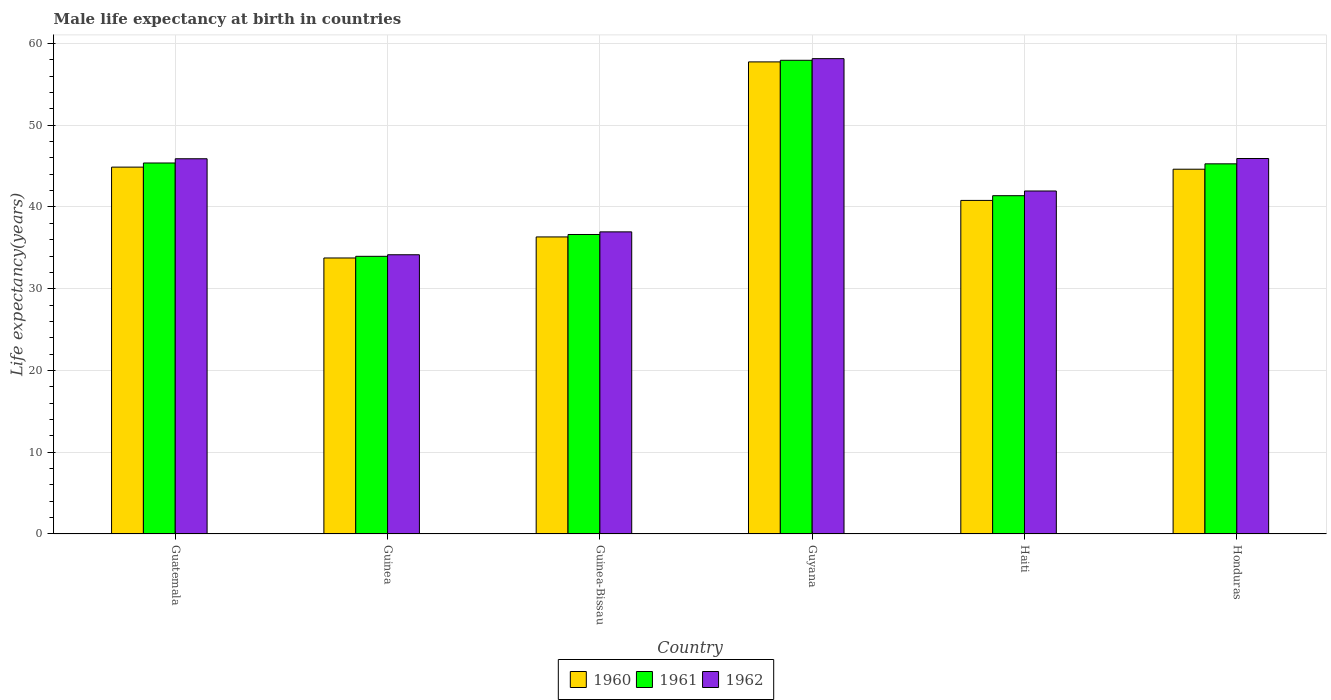How many groups of bars are there?
Your answer should be very brief. 6. Are the number of bars on each tick of the X-axis equal?
Offer a terse response. Yes. What is the label of the 6th group of bars from the left?
Provide a short and direct response. Honduras. What is the male life expectancy at birth in 1961 in Guyana?
Ensure brevity in your answer.  57.95. Across all countries, what is the maximum male life expectancy at birth in 1962?
Your answer should be compact. 58.15. Across all countries, what is the minimum male life expectancy at birth in 1961?
Provide a short and direct response. 33.97. In which country was the male life expectancy at birth in 1962 maximum?
Your answer should be compact. Guyana. In which country was the male life expectancy at birth in 1962 minimum?
Provide a succinct answer. Guinea. What is the total male life expectancy at birth in 1962 in the graph?
Your answer should be compact. 263.05. What is the difference between the male life expectancy at birth in 1962 in Guatemala and that in Guinea?
Offer a very short reply. 11.74. What is the difference between the male life expectancy at birth in 1960 in Guyana and the male life expectancy at birth in 1961 in Guinea-Bissau?
Ensure brevity in your answer.  21.11. What is the average male life expectancy at birth in 1960 per country?
Give a very brief answer. 43.03. What is the difference between the male life expectancy at birth of/in 1962 and male life expectancy at birth of/in 1960 in Guinea?
Give a very brief answer. 0.39. What is the ratio of the male life expectancy at birth in 1960 in Guyana to that in Honduras?
Make the answer very short. 1.29. Is the male life expectancy at birth in 1960 in Guatemala less than that in Honduras?
Your response must be concise. No. Is the difference between the male life expectancy at birth in 1962 in Guatemala and Guinea greater than the difference between the male life expectancy at birth in 1960 in Guatemala and Guinea?
Make the answer very short. Yes. What is the difference between the highest and the second highest male life expectancy at birth in 1961?
Provide a short and direct response. 12.67. What is the difference between the highest and the lowest male life expectancy at birth in 1961?
Provide a succinct answer. 23.98. In how many countries, is the male life expectancy at birth in 1961 greater than the average male life expectancy at birth in 1961 taken over all countries?
Keep it short and to the point. 3. Is the sum of the male life expectancy at birth in 1962 in Guinea and Honduras greater than the maximum male life expectancy at birth in 1961 across all countries?
Your answer should be compact. Yes. What does the 3rd bar from the right in Guyana represents?
Keep it short and to the point. 1960. Is it the case that in every country, the sum of the male life expectancy at birth in 1961 and male life expectancy at birth in 1960 is greater than the male life expectancy at birth in 1962?
Ensure brevity in your answer.  Yes. How many bars are there?
Offer a terse response. 18. Are all the bars in the graph horizontal?
Keep it short and to the point. No. How many countries are there in the graph?
Make the answer very short. 6. What is the difference between two consecutive major ticks on the Y-axis?
Offer a terse response. 10. Are the values on the major ticks of Y-axis written in scientific E-notation?
Make the answer very short. No. Does the graph contain grids?
Provide a short and direct response. Yes. Where does the legend appear in the graph?
Your answer should be very brief. Bottom center. How many legend labels are there?
Offer a very short reply. 3. How are the legend labels stacked?
Your answer should be compact. Horizontal. What is the title of the graph?
Provide a succinct answer. Male life expectancy at birth in countries. What is the label or title of the X-axis?
Give a very brief answer. Country. What is the label or title of the Y-axis?
Make the answer very short. Life expectancy(years). What is the Life expectancy(years) of 1960 in Guatemala?
Provide a succinct answer. 44.88. What is the Life expectancy(years) of 1961 in Guatemala?
Provide a short and direct response. 45.38. What is the Life expectancy(years) in 1962 in Guatemala?
Give a very brief answer. 45.9. What is the Life expectancy(years) in 1960 in Guinea?
Your response must be concise. 33.76. What is the Life expectancy(years) of 1961 in Guinea?
Your answer should be very brief. 33.97. What is the Life expectancy(years) in 1962 in Guinea?
Ensure brevity in your answer.  34.16. What is the Life expectancy(years) of 1960 in Guinea-Bissau?
Offer a very short reply. 36.34. What is the Life expectancy(years) of 1961 in Guinea-Bissau?
Your answer should be compact. 36.63. What is the Life expectancy(years) of 1962 in Guinea-Bissau?
Provide a succinct answer. 36.96. What is the Life expectancy(years) of 1960 in Guyana?
Provide a short and direct response. 57.75. What is the Life expectancy(years) in 1961 in Guyana?
Your response must be concise. 57.95. What is the Life expectancy(years) in 1962 in Guyana?
Ensure brevity in your answer.  58.15. What is the Life expectancy(years) of 1960 in Haiti?
Provide a short and direct response. 40.8. What is the Life expectancy(years) of 1961 in Haiti?
Keep it short and to the point. 41.38. What is the Life expectancy(years) in 1962 in Haiti?
Ensure brevity in your answer.  41.96. What is the Life expectancy(years) in 1960 in Honduras?
Ensure brevity in your answer.  44.62. What is the Life expectancy(years) in 1961 in Honduras?
Keep it short and to the point. 45.28. What is the Life expectancy(years) in 1962 in Honduras?
Make the answer very short. 45.93. Across all countries, what is the maximum Life expectancy(years) of 1960?
Offer a terse response. 57.75. Across all countries, what is the maximum Life expectancy(years) of 1961?
Your answer should be very brief. 57.95. Across all countries, what is the maximum Life expectancy(years) of 1962?
Make the answer very short. 58.15. Across all countries, what is the minimum Life expectancy(years) of 1960?
Keep it short and to the point. 33.76. Across all countries, what is the minimum Life expectancy(years) of 1961?
Provide a short and direct response. 33.97. Across all countries, what is the minimum Life expectancy(years) of 1962?
Make the answer very short. 34.16. What is the total Life expectancy(years) of 1960 in the graph?
Your answer should be very brief. 258.15. What is the total Life expectancy(years) in 1961 in the graph?
Provide a succinct answer. 260.59. What is the total Life expectancy(years) in 1962 in the graph?
Offer a terse response. 263.05. What is the difference between the Life expectancy(years) of 1960 in Guatemala and that in Guinea?
Your answer should be compact. 11.12. What is the difference between the Life expectancy(years) in 1961 in Guatemala and that in Guinea?
Ensure brevity in your answer.  11.42. What is the difference between the Life expectancy(years) of 1962 in Guatemala and that in Guinea?
Provide a succinct answer. 11.74. What is the difference between the Life expectancy(years) in 1960 in Guatemala and that in Guinea-Bissau?
Give a very brief answer. 8.54. What is the difference between the Life expectancy(years) of 1961 in Guatemala and that in Guinea-Bissau?
Offer a very short reply. 8.75. What is the difference between the Life expectancy(years) of 1962 in Guatemala and that in Guinea-Bissau?
Ensure brevity in your answer.  8.94. What is the difference between the Life expectancy(years) in 1960 in Guatemala and that in Guyana?
Provide a succinct answer. -12.87. What is the difference between the Life expectancy(years) of 1961 in Guatemala and that in Guyana?
Your answer should be very brief. -12.56. What is the difference between the Life expectancy(years) of 1962 in Guatemala and that in Guyana?
Your answer should be very brief. -12.25. What is the difference between the Life expectancy(years) in 1960 in Guatemala and that in Haiti?
Ensure brevity in your answer.  4.07. What is the difference between the Life expectancy(years) of 1961 in Guatemala and that in Haiti?
Provide a succinct answer. 4. What is the difference between the Life expectancy(years) in 1962 in Guatemala and that in Haiti?
Give a very brief answer. 3.94. What is the difference between the Life expectancy(years) in 1960 in Guatemala and that in Honduras?
Give a very brief answer. 0.26. What is the difference between the Life expectancy(years) in 1961 in Guatemala and that in Honduras?
Provide a succinct answer. 0.1. What is the difference between the Life expectancy(years) of 1962 in Guatemala and that in Honduras?
Ensure brevity in your answer.  -0.03. What is the difference between the Life expectancy(years) of 1960 in Guinea and that in Guinea-Bissau?
Provide a succinct answer. -2.58. What is the difference between the Life expectancy(years) of 1961 in Guinea and that in Guinea-Bissau?
Make the answer very short. -2.67. What is the difference between the Life expectancy(years) of 1960 in Guinea and that in Guyana?
Keep it short and to the point. -23.99. What is the difference between the Life expectancy(years) of 1961 in Guinea and that in Guyana?
Your answer should be compact. -23.98. What is the difference between the Life expectancy(years) of 1962 in Guinea and that in Guyana?
Provide a succinct answer. -23.99. What is the difference between the Life expectancy(years) of 1960 in Guinea and that in Haiti?
Your answer should be very brief. -7.04. What is the difference between the Life expectancy(years) of 1961 in Guinea and that in Haiti?
Make the answer very short. -7.42. What is the difference between the Life expectancy(years) in 1960 in Guinea and that in Honduras?
Ensure brevity in your answer.  -10.86. What is the difference between the Life expectancy(years) in 1961 in Guinea and that in Honduras?
Provide a short and direct response. -11.31. What is the difference between the Life expectancy(years) of 1962 in Guinea and that in Honduras?
Offer a terse response. -11.78. What is the difference between the Life expectancy(years) of 1960 in Guinea-Bissau and that in Guyana?
Your answer should be very brief. -21.41. What is the difference between the Life expectancy(years) of 1961 in Guinea-Bissau and that in Guyana?
Your answer should be compact. -21.31. What is the difference between the Life expectancy(years) of 1962 in Guinea-Bissau and that in Guyana?
Offer a very short reply. -21.19. What is the difference between the Life expectancy(years) in 1960 in Guinea-Bissau and that in Haiti?
Provide a short and direct response. -4.47. What is the difference between the Life expectancy(years) of 1961 in Guinea-Bissau and that in Haiti?
Your answer should be very brief. -4.75. What is the difference between the Life expectancy(years) of 1962 in Guinea-Bissau and that in Haiti?
Your answer should be compact. -5. What is the difference between the Life expectancy(years) of 1960 in Guinea-Bissau and that in Honduras?
Offer a terse response. -8.28. What is the difference between the Life expectancy(years) of 1961 in Guinea-Bissau and that in Honduras?
Your answer should be compact. -8.64. What is the difference between the Life expectancy(years) of 1962 in Guinea-Bissau and that in Honduras?
Your answer should be compact. -8.97. What is the difference between the Life expectancy(years) in 1960 in Guyana and that in Haiti?
Make the answer very short. 16.94. What is the difference between the Life expectancy(years) of 1961 in Guyana and that in Haiti?
Make the answer very short. 16.56. What is the difference between the Life expectancy(years) of 1962 in Guyana and that in Haiti?
Your answer should be very brief. 16.19. What is the difference between the Life expectancy(years) in 1960 in Guyana and that in Honduras?
Your answer should be compact. 13.13. What is the difference between the Life expectancy(years) in 1961 in Guyana and that in Honduras?
Give a very brief answer. 12.67. What is the difference between the Life expectancy(years) of 1962 in Guyana and that in Honduras?
Your response must be concise. 12.22. What is the difference between the Life expectancy(years) in 1960 in Haiti and that in Honduras?
Your response must be concise. -3.82. What is the difference between the Life expectancy(years) in 1961 in Haiti and that in Honduras?
Ensure brevity in your answer.  -3.9. What is the difference between the Life expectancy(years) of 1962 in Haiti and that in Honduras?
Offer a very short reply. -3.98. What is the difference between the Life expectancy(years) of 1960 in Guatemala and the Life expectancy(years) of 1961 in Guinea?
Keep it short and to the point. 10.91. What is the difference between the Life expectancy(years) of 1960 in Guatemala and the Life expectancy(years) of 1962 in Guinea?
Your answer should be very brief. 10.72. What is the difference between the Life expectancy(years) of 1961 in Guatemala and the Life expectancy(years) of 1962 in Guinea?
Keep it short and to the point. 11.23. What is the difference between the Life expectancy(years) in 1960 in Guatemala and the Life expectancy(years) in 1961 in Guinea-Bissau?
Give a very brief answer. 8.24. What is the difference between the Life expectancy(years) in 1960 in Guatemala and the Life expectancy(years) in 1962 in Guinea-Bissau?
Your answer should be very brief. 7.92. What is the difference between the Life expectancy(years) in 1961 in Guatemala and the Life expectancy(years) in 1962 in Guinea-Bissau?
Provide a short and direct response. 8.43. What is the difference between the Life expectancy(years) of 1960 in Guatemala and the Life expectancy(years) of 1961 in Guyana?
Offer a very short reply. -13.07. What is the difference between the Life expectancy(years) in 1960 in Guatemala and the Life expectancy(years) in 1962 in Guyana?
Keep it short and to the point. -13.27. What is the difference between the Life expectancy(years) in 1961 in Guatemala and the Life expectancy(years) in 1962 in Guyana?
Offer a very short reply. -12.77. What is the difference between the Life expectancy(years) of 1960 in Guatemala and the Life expectancy(years) of 1961 in Haiti?
Your answer should be very brief. 3.5. What is the difference between the Life expectancy(years) of 1960 in Guatemala and the Life expectancy(years) of 1962 in Haiti?
Offer a terse response. 2.92. What is the difference between the Life expectancy(years) in 1961 in Guatemala and the Life expectancy(years) in 1962 in Haiti?
Your answer should be very brief. 3.43. What is the difference between the Life expectancy(years) of 1960 in Guatemala and the Life expectancy(years) of 1961 in Honduras?
Provide a succinct answer. -0.4. What is the difference between the Life expectancy(years) in 1960 in Guatemala and the Life expectancy(years) in 1962 in Honduras?
Provide a short and direct response. -1.05. What is the difference between the Life expectancy(years) in 1961 in Guatemala and the Life expectancy(years) in 1962 in Honduras?
Give a very brief answer. -0.55. What is the difference between the Life expectancy(years) of 1960 in Guinea and the Life expectancy(years) of 1961 in Guinea-Bissau?
Keep it short and to the point. -2.87. What is the difference between the Life expectancy(years) in 1960 in Guinea and the Life expectancy(years) in 1962 in Guinea-Bissau?
Offer a terse response. -3.19. What is the difference between the Life expectancy(years) in 1961 in Guinea and the Life expectancy(years) in 1962 in Guinea-Bissau?
Keep it short and to the point. -2.99. What is the difference between the Life expectancy(years) of 1960 in Guinea and the Life expectancy(years) of 1961 in Guyana?
Provide a short and direct response. -24.18. What is the difference between the Life expectancy(years) of 1960 in Guinea and the Life expectancy(years) of 1962 in Guyana?
Your answer should be compact. -24.39. What is the difference between the Life expectancy(years) of 1961 in Guinea and the Life expectancy(years) of 1962 in Guyana?
Your answer should be compact. -24.18. What is the difference between the Life expectancy(years) of 1960 in Guinea and the Life expectancy(years) of 1961 in Haiti?
Ensure brevity in your answer.  -7.62. What is the difference between the Life expectancy(years) of 1960 in Guinea and the Life expectancy(years) of 1962 in Haiti?
Make the answer very short. -8.19. What is the difference between the Life expectancy(years) in 1961 in Guinea and the Life expectancy(years) in 1962 in Haiti?
Provide a succinct answer. -7.99. What is the difference between the Life expectancy(years) in 1960 in Guinea and the Life expectancy(years) in 1961 in Honduras?
Provide a short and direct response. -11.52. What is the difference between the Life expectancy(years) of 1960 in Guinea and the Life expectancy(years) of 1962 in Honduras?
Give a very brief answer. -12.17. What is the difference between the Life expectancy(years) of 1961 in Guinea and the Life expectancy(years) of 1962 in Honduras?
Your answer should be compact. -11.96. What is the difference between the Life expectancy(years) of 1960 in Guinea-Bissau and the Life expectancy(years) of 1961 in Guyana?
Provide a short and direct response. -21.61. What is the difference between the Life expectancy(years) in 1960 in Guinea-Bissau and the Life expectancy(years) in 1962 in Guyana?
Provide a short and direct response. -21.81. What is the difference between the Life expectancy(years) of 1961 in Guinea-Bissau and the Life expectancy(years) of 1962 in Guyana?
Ensure brevity in your answer.  -21.51. What is the difference between the Life expectancy(years) of 1960 in Guinea-Bissau and the Life expectancy(years) of 1961 in Haiti?
Provide a short and direct response. -5.04. What is the difference between the Life expectancy(years) in 1960 in Guinea-Bissau and the Life expectancy(years) in 1962 in Haiti?
Make the answer very short. -5.62. What is the difference between the Life expectancy(years) of 1961 in Guinea-Bissau and the Life expectancy(years) of 1962 in Haiti?
Make the answer very short. -5.32. What is the difference between the Life expectancy(years) of 1960 in Guinea-Bissau and the Life expectancy(years) of 1961 in Honduras?
Make the answer very short. -8.94. What is the difference between the Life expectancy(years) in 1960 in Guinea-Bissau and the Life expectancy(years) in 1962 in Honduras?
Your answer should be very brief. -9.59. What is the difference between the Life expectancy(years) of 1961 in Guinea-Bissau and the Life expectancy(years) of 1962 in Honduras?
Your answer should be compact. -9.3. What is the difference between the Life expectancy(years) of 1960 in Guyana and the Life expectancy(years) of 1961 in Haiti?
Offer a terse response. 16.37. What is the difference between the Life expectancy(years) in 1960 in Guyana and the Life expectancy(years) in 1962 in Haiti?
Provide a succinct answer. 15.79. What is the difference between the Life expectancy(years) of 1961 in Guyana and the Life expectancy(years) of 1962 in Haiti?
Provide a succinct answer. 15.99. What is the difference between the Life expectancy(years) in 1960 in Guyana and the Life expectancy(years) in 1961 in Honduras?
Provide a short and direct response. 12.47. What is the difference between the Life expectancy(years) in 1960 in Guyana and the Life expectancy(years) in 1962 in Honduras?
Offer a terse response. 11.82. What is the difference between the Life expectancy(years) of 1961 in Guyana and the Life expectancy(years) of 1962 in Honduras?
Make the answer very short. 12.02. What is the difference between the Life expectancy(years) of 1960 in Haiti and the Life expectancy(years) of 1961 in Honduras?
Your answer should be compact. -4.47. What is the difference between the Life expectancy(years) of 1960 in Haiti and the Life expectancy(years) of 1962 in Honduras?
Offer a terse response. -5.13. What is the difference between the Life expectancy(years) in 1961 in Haiti and the Life expectancy(years) in 1962 in Honduras?
Provide a short and direct response. -4.55. What is the average Life expectancy(years) in 1960 per country?
Your answer should be compact. 43.02. What is the average Life expectancy(years) of 1961 per country?
Keep it short and to the point. 43.43. What is the average Life expectancy(years) in 1962 per country?
Your answer should be very brief. 43.84. What is the difference between the Life expectancy(years) in 1960 and Life expectancy(years) in 1961 in Guatemala?
Your response must be concise. -0.51. What is the difference between the Life expectancy(years) of 1960 and Life expectancy(years) of 1962 in Guatemala?
Ensure brevity in your answer.  -1.02. What is the difference between the Life expectancy(years) of 1961 and Life expectancy(years) of 1962 in Guatemala?
Ensure brevity in your answer.  -0.52. What is the difference between the Life expectancy(years) in 1960 and Life expectancy(years) in 1961 in Guinea?
Offer a very short reply. -0.2. What is the difference between the Life expectancy(years) of 1960 and Life expectancy(years) of 1962 in Guinea?
Your answer should be compact. -0.39. What is the difference between the Life expectancy(years) in 1961 and Life expectancy(years) in 1962 in Guinea?
Give a very brief answer. -0.19. What is the difference between the Life expectancy(years) of 1960 and Life expectancy(years) of 1961 in Guinea-Bissau?
Offer a very short reply. -0.3. What is the difference between the Life expectancy(years) of 1960 and Life expectancy(years) of 1962 in Guinea-Bissau?
Offer a terse response. -0.62. What is the difference between the Life expectancy(years) in 1961 and Life expectancy(years) in 1962 in Guinea-Bissau?
Make the answer very short. -0.32. What is the difference between the Life expectancy(years) in 1960 and Life expectancy(years) in 1961 in Guyana?
Your answer should be compact. -0.2. What is the difference between the Life expectancy(years) of 1960 and Life expectancy(years) of 1962 in Guyana?
Ensure brevity in your answer.  -0.4. What is the difference between the Life expectancy(years) of 1961 and Life expectancy(years) of 1962 in Guyana?
Give a very brief answer. -0.2. What is the difference between the Life expectancy(years) of 1960 and Life expectancy(years) of 1961 in Haiti?
Offer a terse response. -0.58. What is the difference between the Life expectancy(years) in 1960 and Life expectancy(years) in 1962 in Haiti?
Provide a succinct answer. -1.15. What is the difference between the Life expectancy(years) of 1961 and Life expectancy(years) of 1962 in Haiti?
Offer a terse response. -0.57. What is the difference between the Life expectancy(years) of 1960 and Life expectancy(years) of 1961 in Honduras?
Your answer should be very brief. -0.66. What is the difference between the Life expectancy(years) of 1960 and Life expectancy(years) of 1962 in Honduras?
Your answer should be compact. -1.31. What is the difference between the Life expectancy(years) of 1961 and Life expectancy(years) of 1962 in Honduras?
Make the answer very short. -0.65. What is the ratio of the Life expectancy(years) of 1960 in Guatemala to that in Guinea?
Offer a very short reply. 1.33. What is the ratio of the Life expectancy(years) in 1961 in Guatemala to that in Guinea?
Provide a succinct answer. 1.34. What is the ratio of the Life expectancy(years) of 1962 in Guatemala to that in Guinea?
Offer a very short reply. 1.34. What is the ratio of the Life expectancy(years) of 1960 in Guatemala to that in Guinea-Bissau?
Your response must be concise. 1.24. What is the ratio of the Life expectancy(years) of 1961 in Guatemala to that in Guinea-Bissau?
Your answer should be very brief. 1.24. What is the ratio of the Life expectancy(years) of 1962 in Guatemala to that in Guinea-Bissau?
Provide a short and direct response. 1.24. What is the ratio of the Life expectancy(years) of 1960 in Guatemala to that in Guyana?
Your answer should be compact. 0.78. What is the ratio of the Life expectancy(years) in 1961 in Guatemala to that in Guyana?
Ensure brevity in your answer.  0.78. What is the ratio of the Life expectancy(years) of 1962 in Guatemala to that in Guyana?
Ensure brevity in your answer.  0.79. What is the ratio of the Life expectancy(years) in 1960 in Guatemala to that in Haiti?
Your response must be concise. 1.1. What is the ratio of the Life expectancy(years) of 1961 in Guatemala to that in Haiti?
Offer a terse response. 1.1. What is the ratio of the Life expectancy(years) in 1962 in Guatemala to that in Haiti?
Make the answer very short. 1.09. What is the ratio of the Life expectancy(years) of 1961 in Guatemala to that in Honduras?
Your answer should be very brief. 1. What is the ratio of the Life expectancy(years) in 1960 in Guinea to that in Guinea-Bissau?
Offer a very short reply. 0.93. What is the ratio of the Life expectancy(years) of 1961 in Guinea to that in Guinea-Bissau?
Provide a short and direct response. 0.93. What is the ratio of the Life expectancy(years) of 1962 in Guinea to that in Guinea-Bissau?
Keep it short and to the point. 0.92. What is the ratio of the Life expectancy(years) in 1960 in Guinea to that in Guyana?
Make the answer very short. 0.58. What is the ratio of the Life expectancy(years) of 1961 in Guinea to that in Guyana?
Provide a succinct answer. 0.59. What is the ratio of the Life expectancy(years) in 1962 in Guinea to that in Guyana?
Give a very brief answer. 0.59. What is the ratio of the Life expectancy(years) of 1960 in Guinea to that in Haiti?
Provide a succinct answer. 0.83. What is the ratio of the Life expectancy(years) in 1961 in Guinea to that in Haiti?
Provide a short and direct response. 0.82. What is the ratio of the Life expectancy(years) of 1962 in Guinea to that in Haiti?
Provide a succinct answer. 0.81. What is the ratio of the Life expectancy(years) of 1960 in Guinea to that in Honduras?
Provide a succinct answer. 0.76. What is the ratio of the Life expectancy(years) of 1961 in Guinea to that in Honduras?
Keep it short and to the point. 0.75. What is the ratio of the Life expectancy(years) of 1962 in Guinea to that in Honduras?
Offer a very short reply. 0.74. What is the ratio of the Life expectancy(years) of 1960 in Guinea-Bissau to that in Guyana?
Give a very brief answer. 0.63. What is the ratio of the Life expectancy(years) of 1961 in Guinea-Bissau to that in Guyana?
Your response must be concise. 0.63. What is the ratio of the Life expectancy(years) of 1962 in Guinea-Bissau to that in Guyana?
Make the answer very short. 0.64. What is the ratio of the Life expectancy(years) of 1960 in Guinea-Bissau to that in Haiti?
Ensure brevity in your answer.  0.89. What is the ratio of the Life expectancy(years) of 1961 in Guinea-Bissau to that in Haiti?
Keep it short and to the point. 0.89. What is the ratio of the Life expectancy(years) of 1962 in Guinea-Bissau to that in Haiti?
Offer a very short reply. 0.88. What is the ratio of the Life expectancy(years) in 1960 in Guinea-Bissau to that in Honduras?
Make the answer very short. 0.81. What is the ratio of the Life expectancy(years) in 1961 in Guinea-Bissau to that in Honduras?
Offer a terse response. 0.81. What is the ratio of the Life expectancy(years) in 1962 in Guinea-Bissau to that in Honduras?
Provide a succinct answer. 0.8. What is the ratio of the Life expectancy(years) in 1960 in Guyana to that in Haiti?
Keep it short and to the point. 1.42. What is the ratio of the Life expectancy(years) in 1961 in Guyana to that in Haiti?
Provide a short and direct response. 1.4. What is the ratio of the Life expectancy(years) of 1962 in Guyana to that in Haiti?
Give a very brief answer. 1.39. What is the ratio of the Life expectancy(years) in 1960 in Guyana to that in Honduras?
Offer a terse response. 1.29. What is the ratio of the Life expectancy(years) of 1961 in Guyana to that in Honduras?
Provide a short and direct response. 1.28. What is the ratio of the Life expectancy(years) in 1962 in Guyana to that in Honduras?
Make the answer very short. 1.27. What is the ratio of the Life expectancy(years) of 1960 in Haiti to that in Honduras?
Make the answer very short. 0.91. What is the ratio of the Life expectancy(years) in 1961 in Haiti to that in Honduras?
Offer a very short reply. 0.91. What is the ratio of the Life expectancy(years) in 1962 in Haiti to that in Honduras?
Ensure brevity in your answer.  0.91. What is the difference between the highest and the second highest Life expectancy(years) in 1960?
Offer a terse response. 12.87. What is the difference between the highest and the second highest Life expectancy(years) of 1961?
Your answer should be very brief. 12.56. What is the difference between the highest and the second highest Life expectancy(years) in 1962?
Ensure brevity in your answer.  12.22. What is the difference between the highest and the lowest Life expectancy(years) of 1960?
Give a very brief answer. 23.99. What is the difference between the highest and the lowest Life expectancy(years) of 1961?
Provide a succinct answer. 23.98. What is the difference between the highest and the lowest Life expectancy(years) of 1962?
Provide a short and direct response. 23.99. 